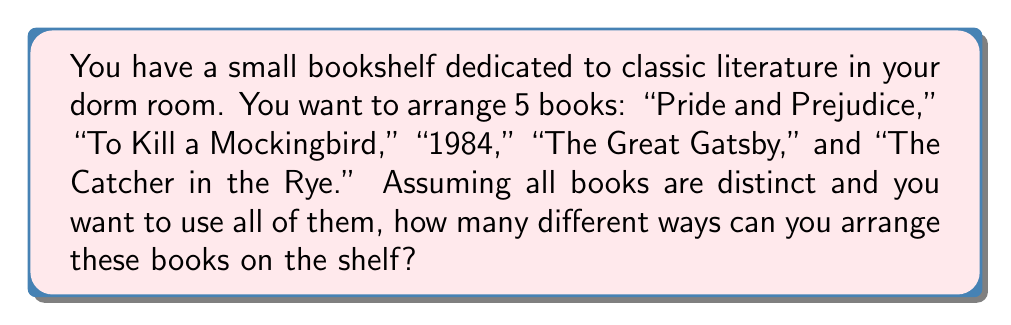Can you answer this question? This problem is a perfect application of permutations in Group theory. Since we're dealing with arranging distinct objects (the books) in a specific order, we can use the concept of permutations.

Let's approach this step-by-step:

1. We have 5 distinct books, and we want to arrange all of them.

2. For the first position on the shelf, we have 5 choices (any of the 5 books can go first).

3. After placing the first book, we have 4 books left for the second position.

4. For the third position, we'll have 3 choices remaining, and so on.

5. This gives us the following calculation:

   $$ 5 \times 4 \times 3 \times 2 \times 1 $$

6. In mathematical notation, this is written as 5! (5 factorial).

7. We can calculate this:

   $$ 5! = 5 \times 4 \times 3 \times 2 \times 1 = 120 $$

Therefore, there are 120 different ways to arrange these 5 classic literature books on your shelf.

This concept is fundamental in Group theory, particularly in the study of symmetric groups. The symmetric group on a set of n elements, often denoted as $S_n$, has n! elements, each representing a unique permutation of those n elements.
Answer: 120 